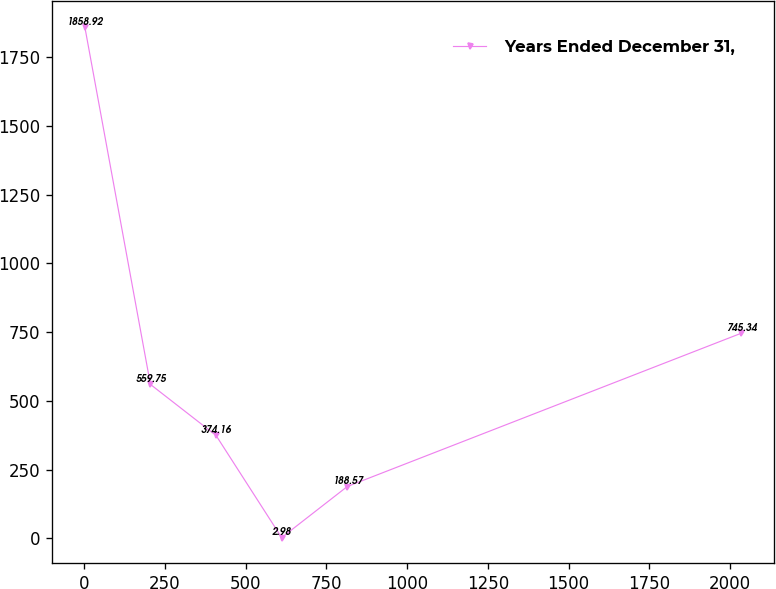Convert chart to OTSL. <chart><loc_0><loc_0><loc_500><loc_500><line_chart><ecel><fcel>Years Ended December 31,<nl><fcel>2.55<fcel>1858.92<nl><fcel>205.63<fcel>559.75<nl><fcel>408.71<fcel>374.16<nl><fcel>611.79<fcel>2.98<nl><fcel>814.87<fcel>188.57<nl><fcel>2033.36<fcel>745.34<nl></chart> 